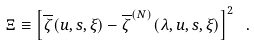<formula> <loc_0><loc_0><loc_500><loc_500>\Xi \equiv \left [ \overline { \zeta } ( u , s , \xi ) - \overline { \zeta } ^ { ( N ) } ( \lambda , u , s , \xi ) \right ] ^ { 2 } \ .</formula> 